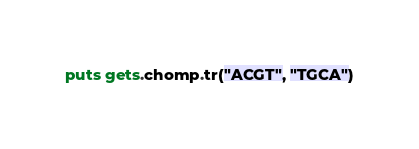<code> <loc_0><loc_0><loc_500><loc_500><_Ruby_>puts gets.chomp.tr("ACGT", "TGCA")
</code> 